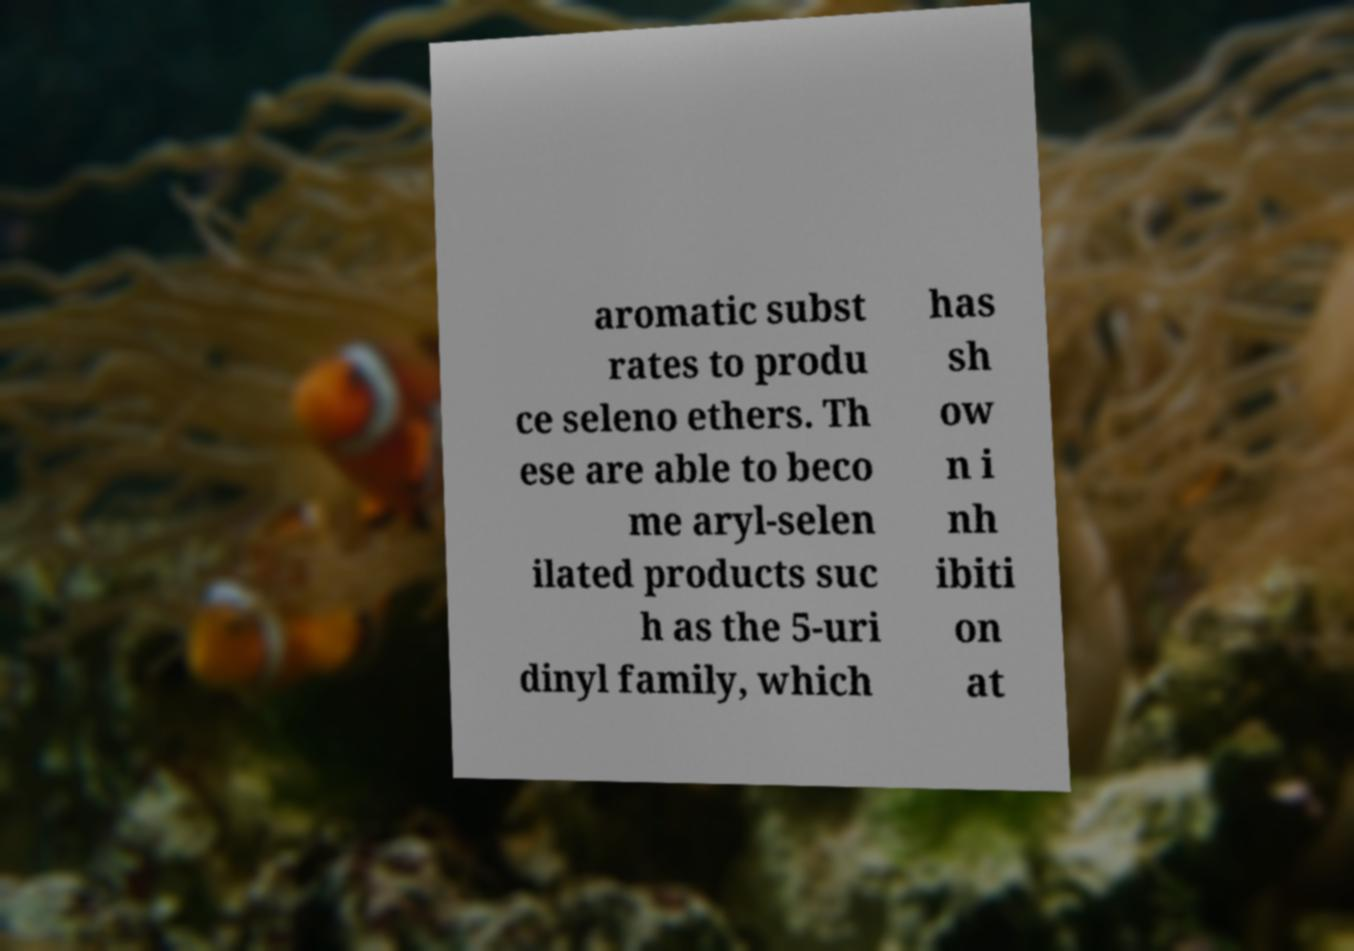Please identify and transcribe the text found in this image. aromatic subst rates to produ ce seleno ethers. Th ese are able to beco me aryl-selen ilated products suc h as the 5-uri dinyl family, which has sh ow n i nh ibiti on at 